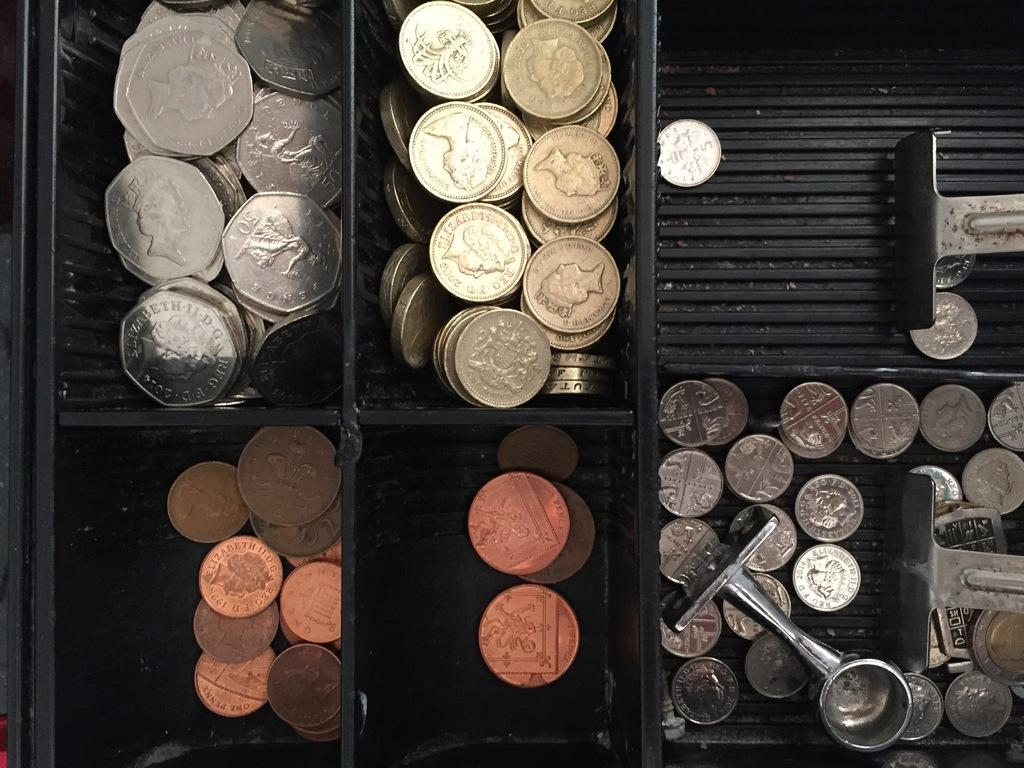Provide a one-sentence caption for the provided image. The fifty cent silver piece on the left has Queen Elizabeth II D.G. on it. 